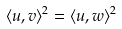Convert formula to latex. <formula><loc_0><loc_0><loc_500><loc_500>\langle u , v \rangle ^ { 2 } = \langle u , w \rangle ^ { 2 }</formula> 